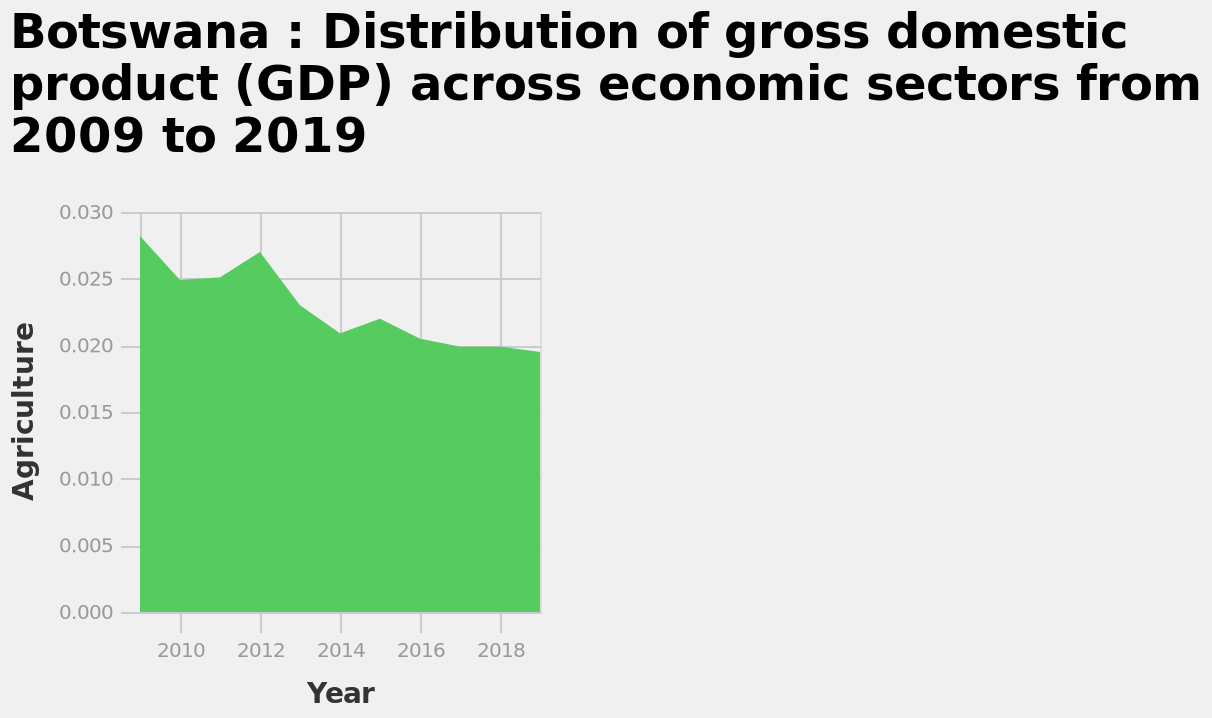<image>
What is the trend of GDP from agriculture in Botswana over the past decade? The trend of GDP from agriculture in Botswana over the past decade has been a decline. please summary the statistics and relations of the chart GDP in Botswana’s agricultural sector has seen a downward trend between 2010 and 2018. What has been the trend of GDP from agriculture in Botswana between 2009 to 2019? The trend of GDP from agriculture in Botswana has been on a downward trend between 2009 to 2019. Has GDP from agriculture in Botswana been increasing or decreasing from 2009 to 2019? GDP from agriculture in Botswana has been decreasing from 2009 to 2019. 